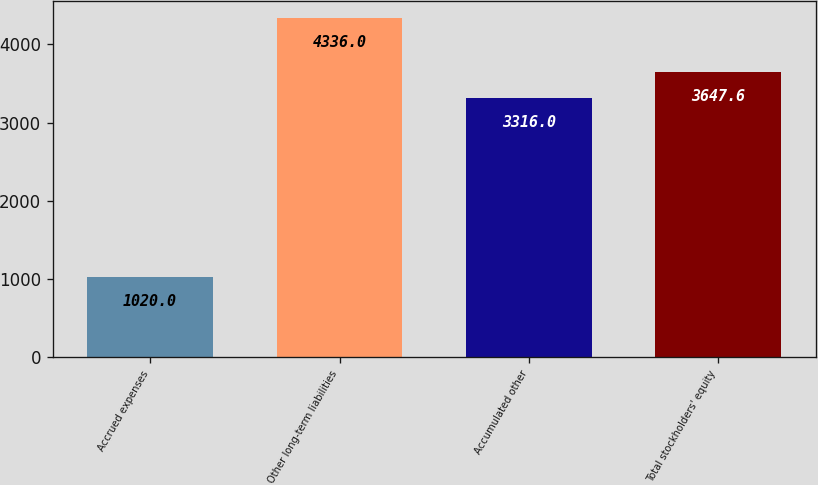Convert chart to OTSL. <chart><loc_0><loc_0><loc_500><loc_500><bar_chart><fcel>Accrued expenses<fcel>Other long-term liabilities<fcel>Accumulated other<fcel>Total stockholders' equity<nl><fcel>1020<fcel>4336<fcel>3316<fcel>3647.6<nl></chart> 